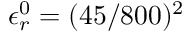Convert formula to latex. <formula><loc_0><loc_0><loc_500><loc_500>\epsilon _ { r } ^ { 0 } = ( 4 5 / 8 0 0 ) ^ { 2 }</formula> 